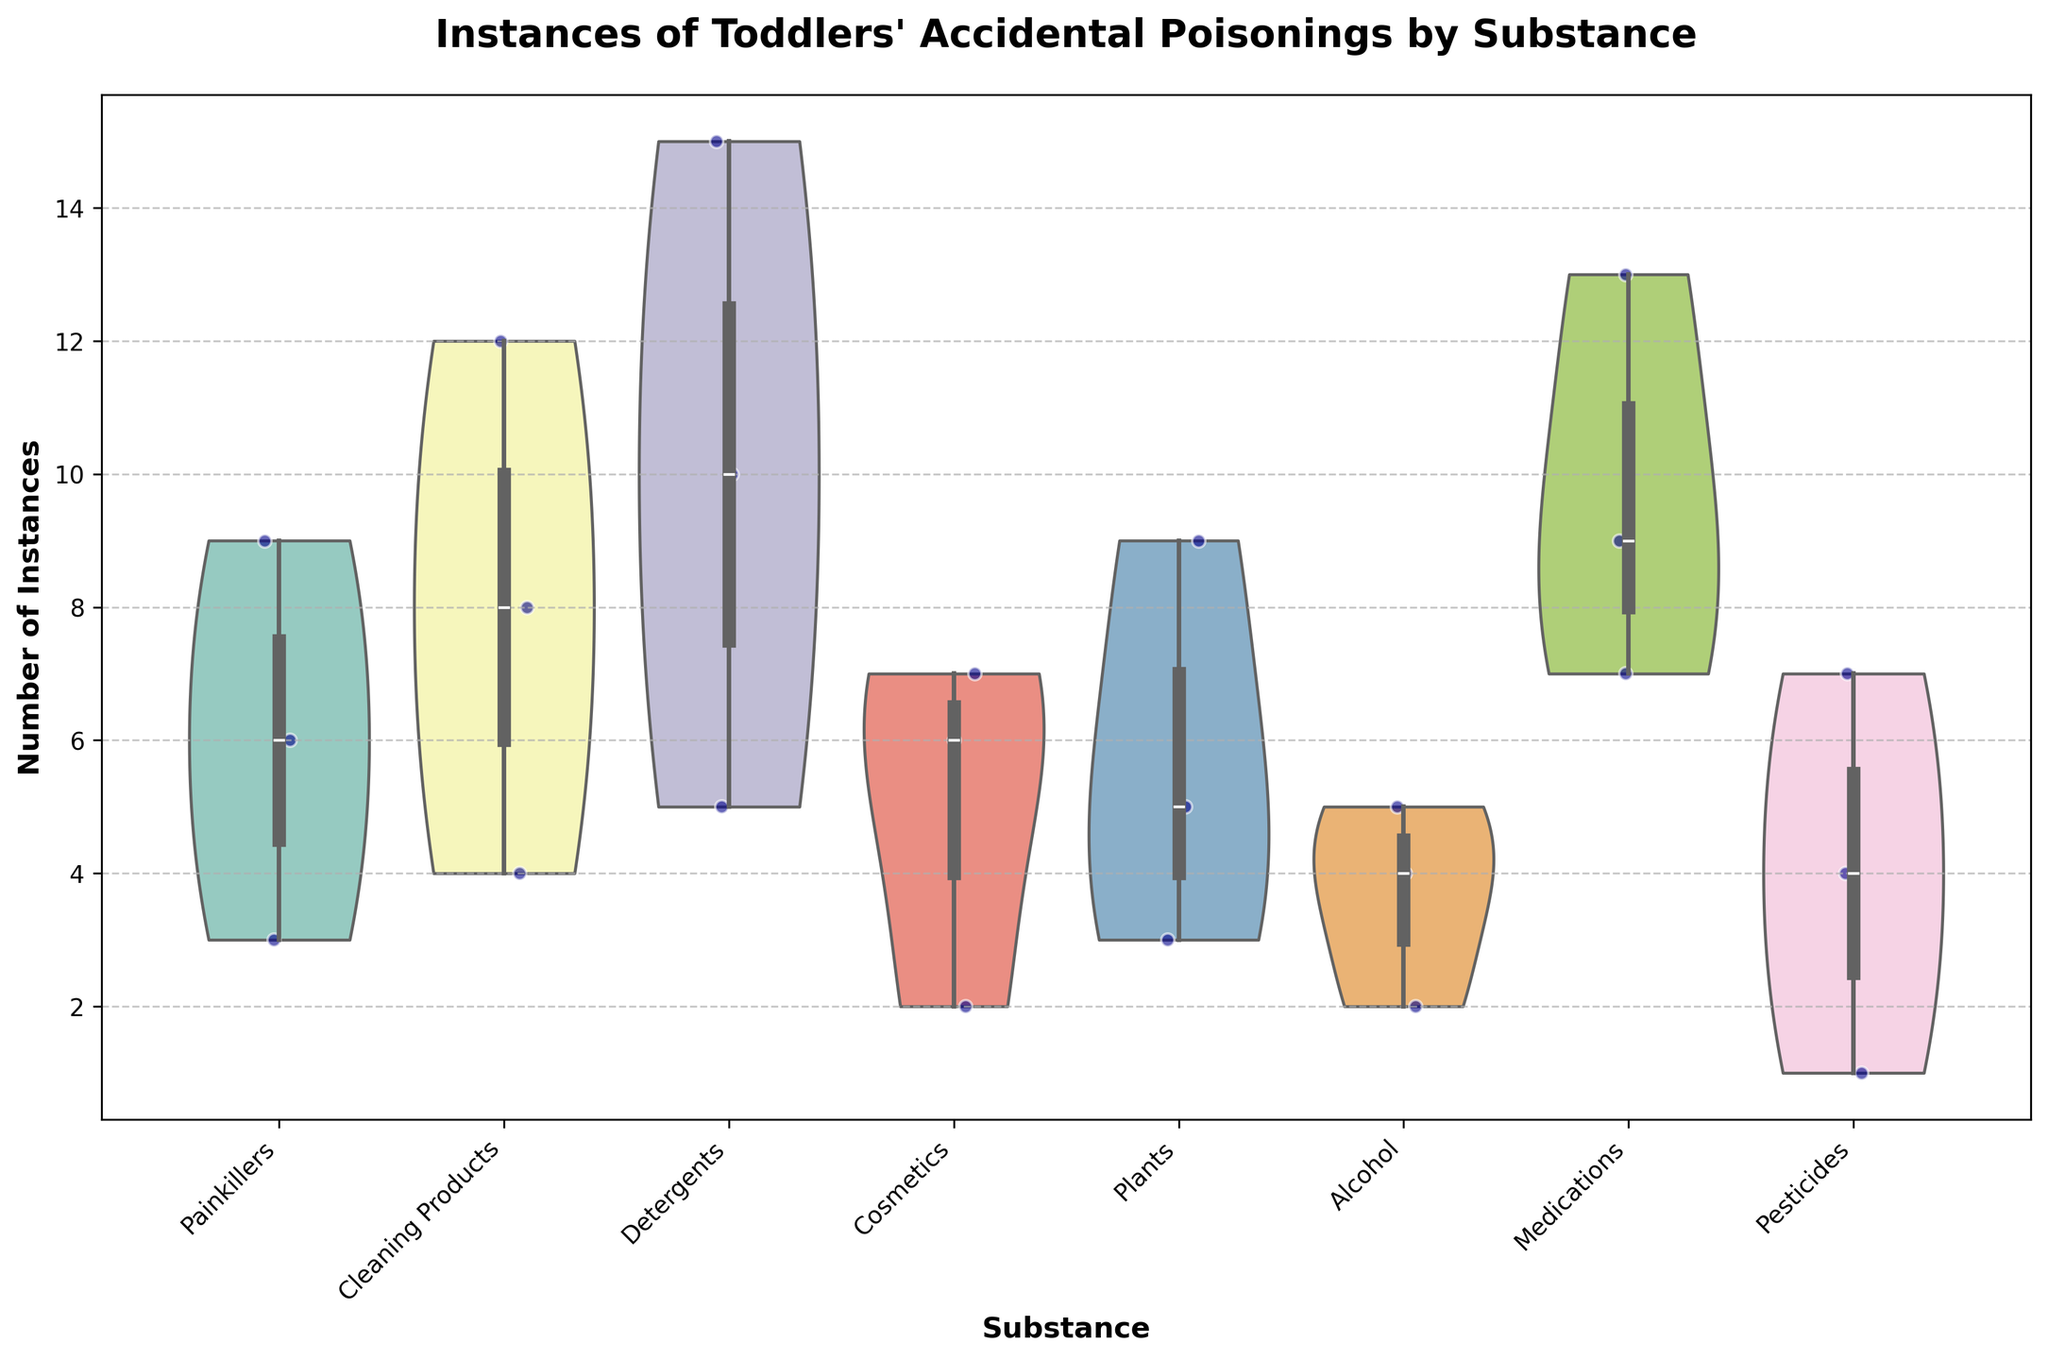What is the title of the figure? The title is located at the top of the figure and describes its content, which is "Instances of Toddlers' Accidental Poisonings by Substance."
Answer: Instances of Toddlers' Accidental Poisonings by Substance What are the substances listed on the x-axis? The x-axis labels can be read directly from the figure; they include various substances that caused the poisonings.
Answer: Painkillers, Cleaning Products, Detergents, Cosmetics, Plants, Alcohol, Medications, Pesticides Which substance has the highest number of poisoning instances? By looking at the violin shapes' spread and peaks, the one with the highest value can be identified. The substance with the highest peak is "Medications."
Answer: Medications How many instances of poisoning occurred in the living room with cleaning products? Identify the points for Cleaning Products in the Living Room from the jittered points and count them. There are 4 such instances.
Answer: 4 What's the average number of instances for Painkillers? List the instances for Painkillers (6, 9, 3), then compute the average: (6+9+3)/3 = 6.
Answer: 6 Which two substances show the most similar distribution of instances? To answer this, visually compare the shapes of the violin plots and the distribution of points. The distributions for "Painkillers" and "Alcohol" are quite similar in shape and spread.
Answer: Painkillers and Alcohol Is the median number of poisoning instances higher for Detergents or Plants? For median values, inspect the thick part of the inner box plot within the violin. The median point for Detergents looks higher than that for Plants.
Answer: Detergents Which home environment shows the highest overall number of poisoning instances across all substances? Sum the instances within each home environment (e.g., Kitchen: 6+12+10+4+7 = 39). Compare the sums for each environment to find the highest. The Kitchen has the highest total.
Answer: Kitchen Do any substances have outliers in their poisoning instances? Outliers are visible as individual points far from the bulk of the data within each violin plot. The substance "Detergents" has a few instances noticeably separate, which could be considered outliers.
Answer: Detergents What is the range of instances for Medications? Identify the minimum and maximum points within the violin plot for Medications. The minimum is 7 and the maximum is 13, giving a range of 6.
Answer: 6 